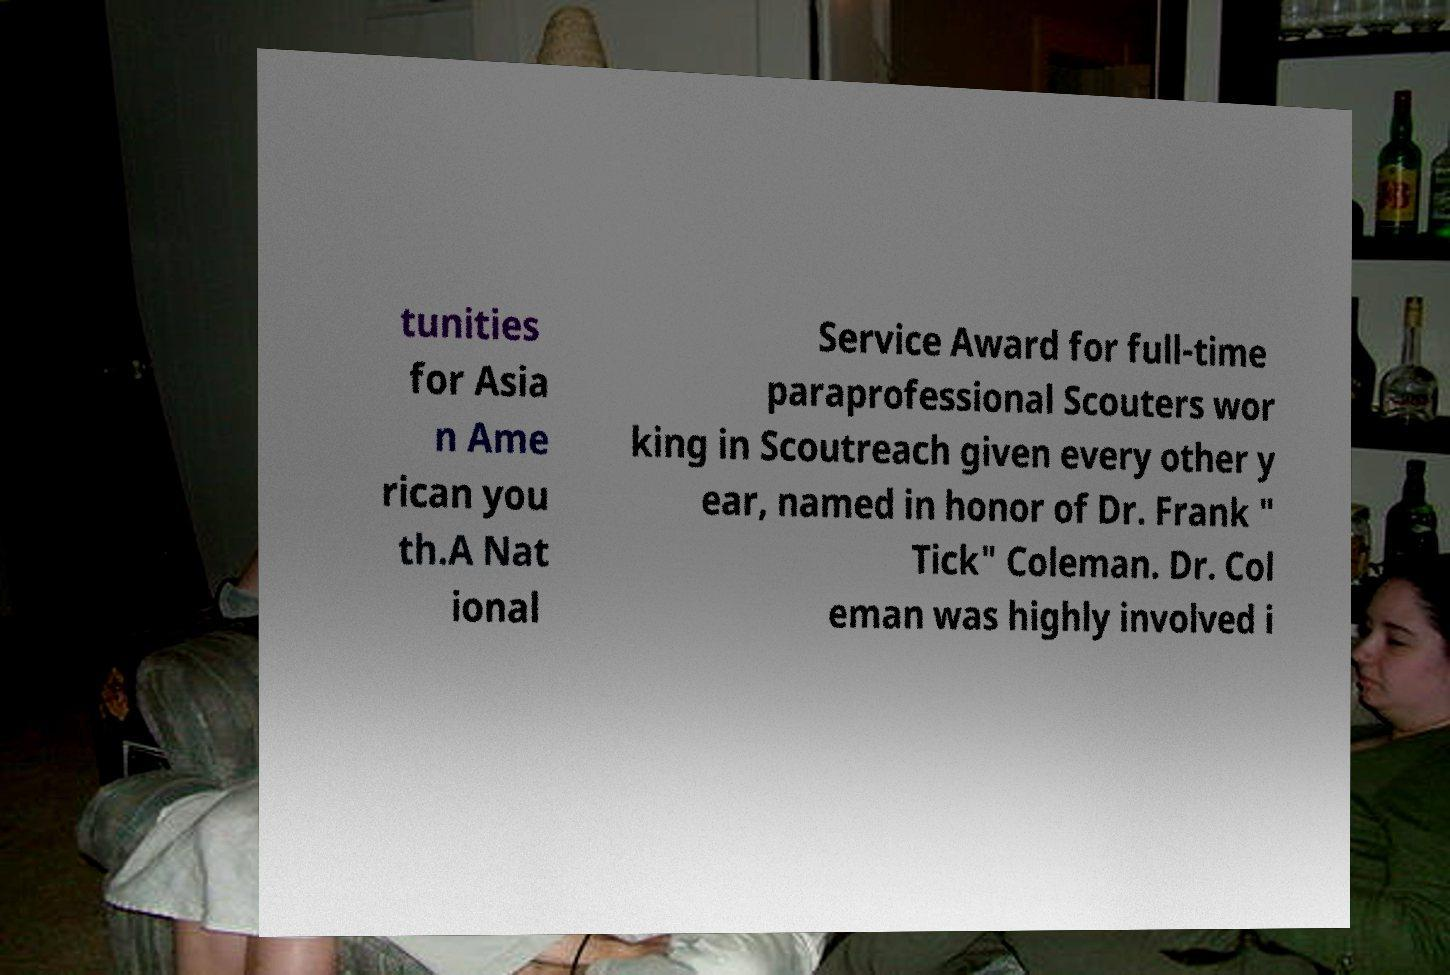Could you assist in decoding the text presented in this image and type it out clearly? tunities for Asia n Ame rican you th.A Nat ional Service Award for full-time paraprofessional Scouters wor king in Scoutreach given every other y ear, named in honor of Dr. Frank " Tick" Coleman. Dr. Col eman was highly involved i 